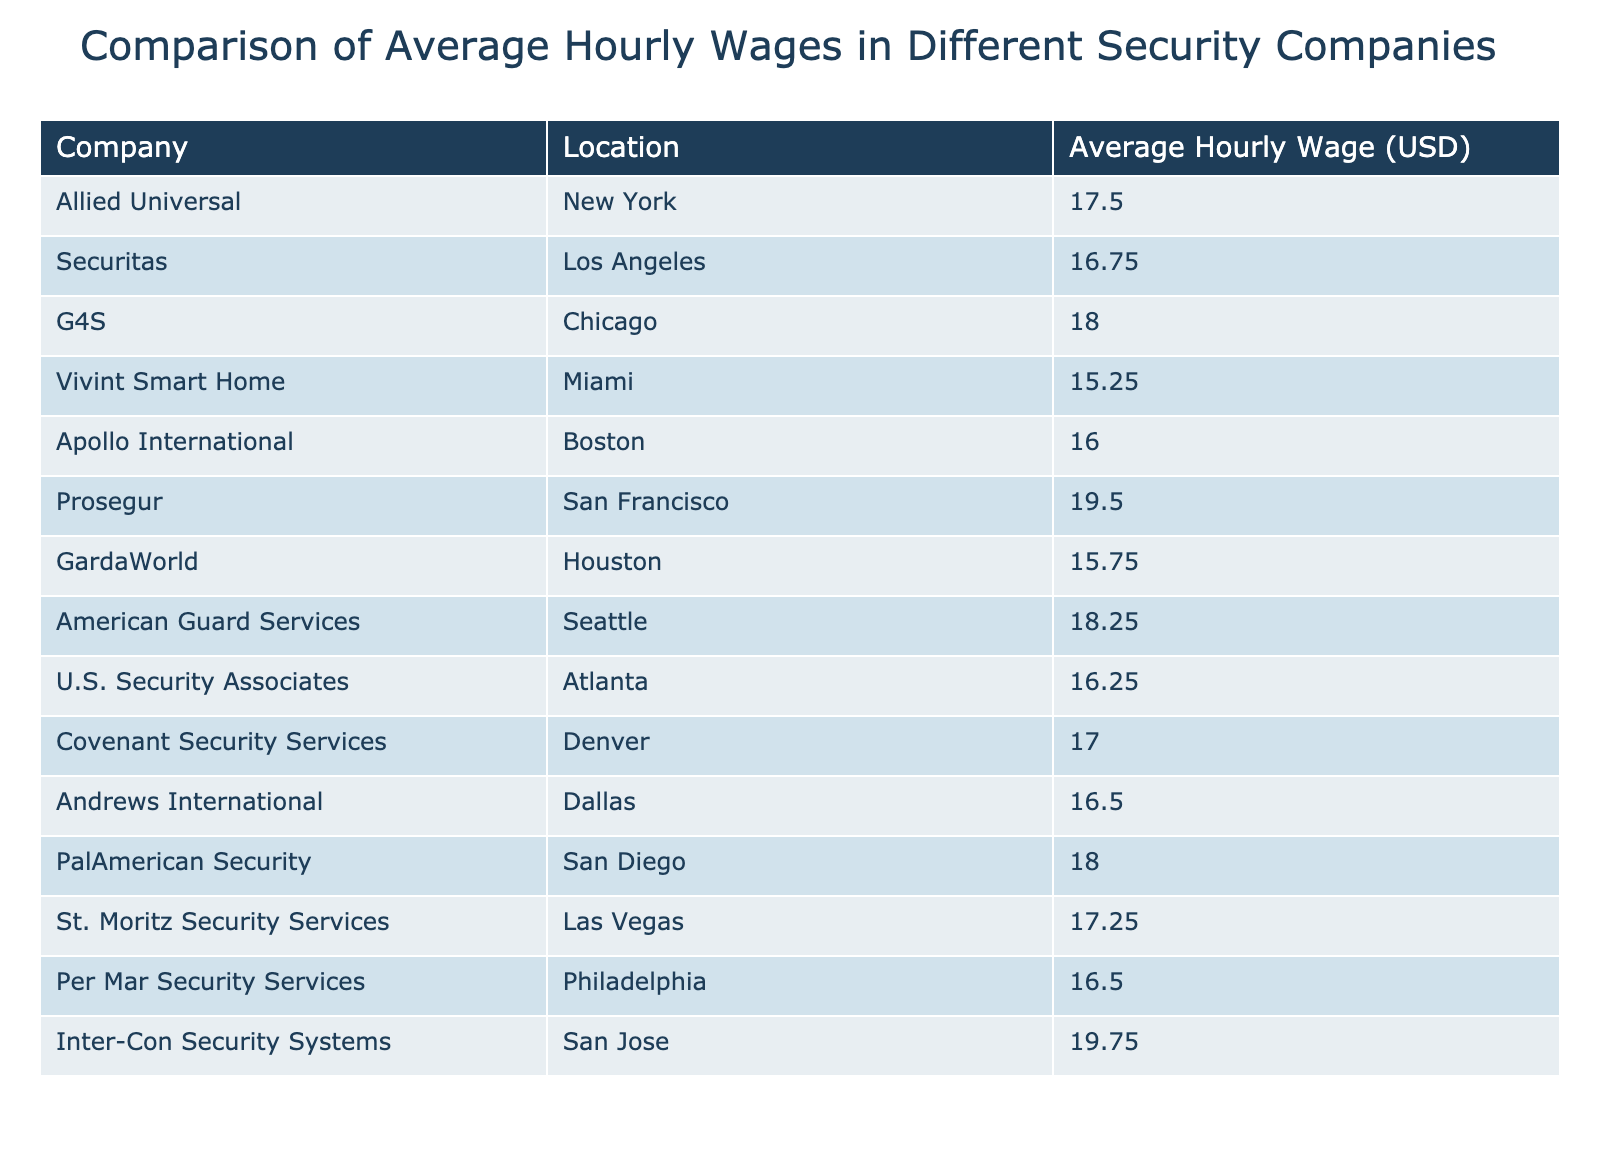What is the highest average hourly wage among the security companies listed? The table lists the following average hourly wages: 17.50, 16.75, 18.00, 15.25, 16.00, 19.50, 15.75, 18.25, 16.25, 17.00, 16.50, 18.00, 17.25, 16.50, and 19.75. The highest of these values is 19.75, corresponding to Inter-Con Security Systems.
Answer: 19.75 Which company has the lowest average hourly wage? From the data, the average hourly wages include a minimum of 15.25 for Vivint Smart Home. By looking through the list, this is the lowest value, indicating that Vivint Smart Home pays the least per hour among the companies.
Answer: Vivint Smart Home What is the average hourly wage of all the companies combined? To calculate the average hourly wage, we first sum the values: (17.50 + 16.75 + 18.00 + 15.25 + 16.00 + 19.50 + 15.75 + 18.25 + 16.25 + 17.00 + 16.50 + 18.00 + 17.25 + 16.50 + 19.75) =  17.25. We have 15 companies, so we divide the total wage sum by 15, giving us an average of 17.25.
Answer: 17.25 Is there any company located in Miami that pays more than 18 dollars per hour? The company in Miami listed in the table is Vivint Smart Home, which has an average hourly wage of 15.25. Since this amount is less than 18, there are no companies in Miami that pay more than that amount.
Answer: No Which companies pay between 16 and 18 dollars per hour? Looking at the hourly wages within the range of 16 and 18 dollars, the corresponding companies are Allied Universal (17.50), Securitas (16.75), Apollo International (16.00), Covenant Security Services (17.00), Andrews International (16.50), and PalAmerican Security (18.00). This gives us a total of 6 companies that fit within this wage range.
Answer: 6 companies 